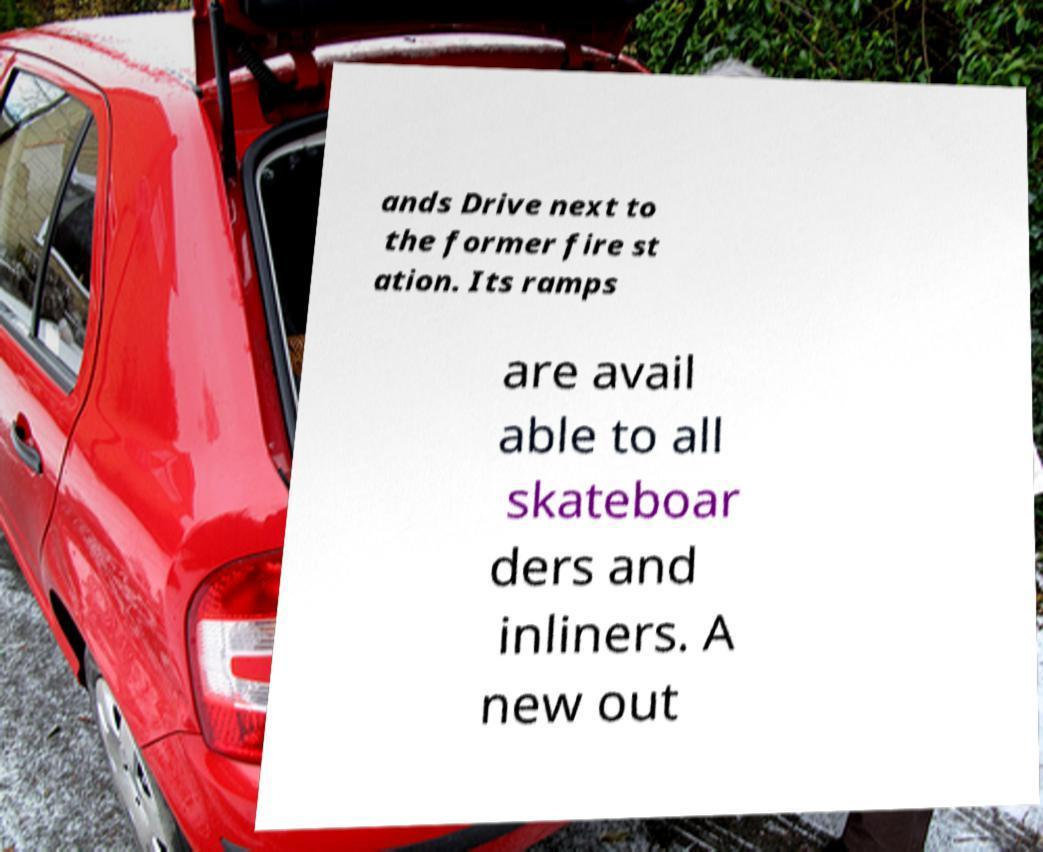Please read and relay the text visible in this image. What does it say? ands Drive next to the former fire st ation. Its ramps are avail able to all skateboar ders and inliners. A new out 